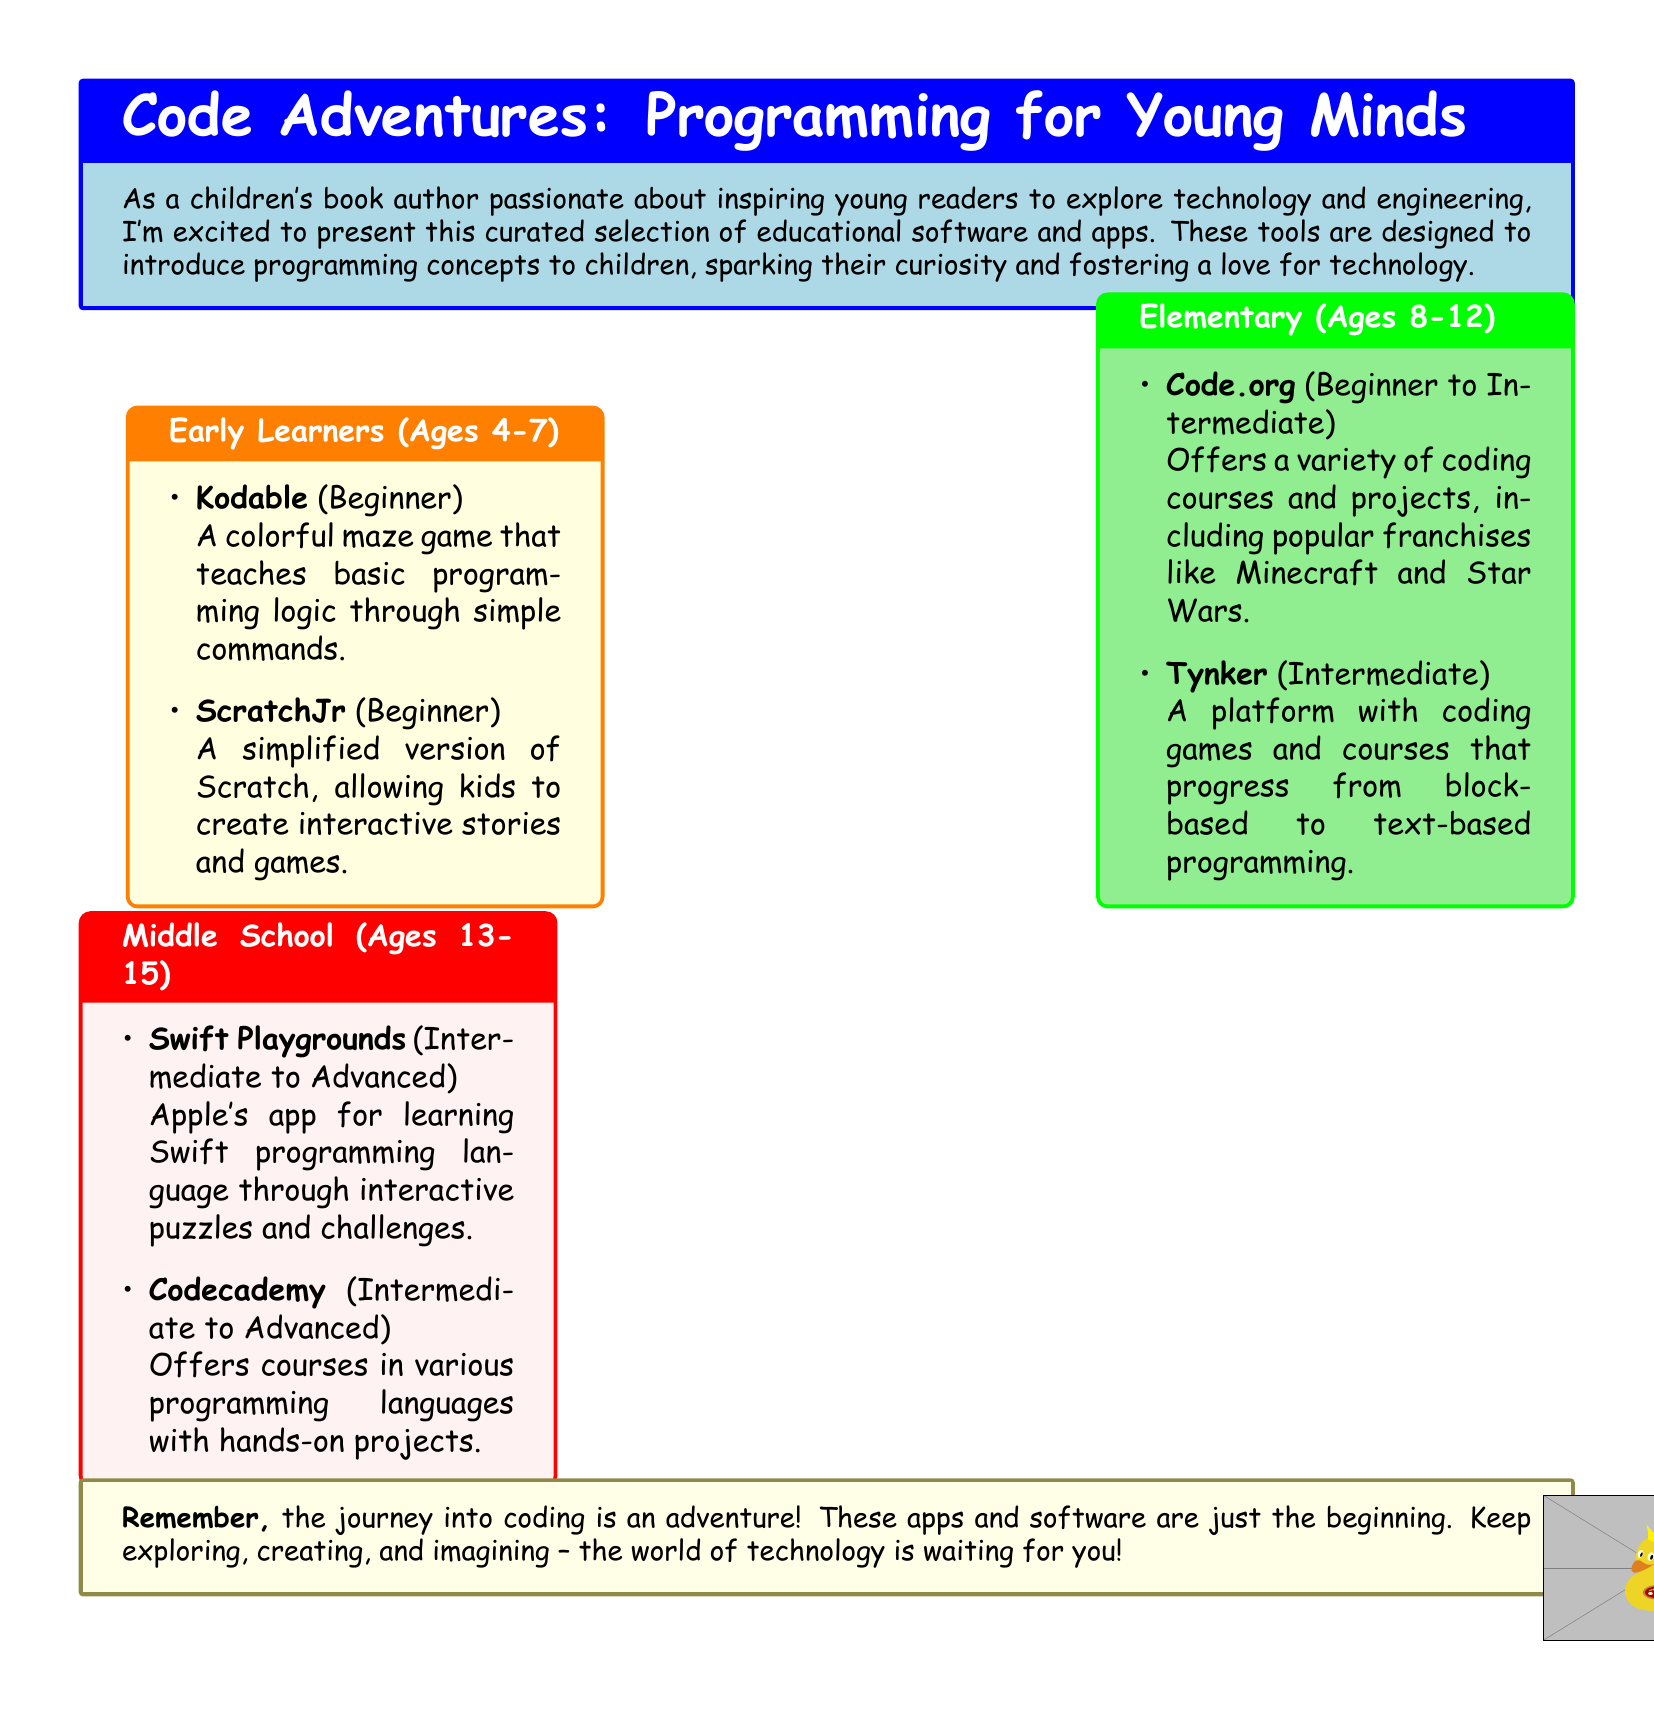What age group is Kodable designed for? Kodable is listed under Early Learners, which caters to ages 4-7.
Answer: Ages 4-7 What programming language does Swift Playgrounds teach? Swift Playgrounds is designed to help users learn the Swift programming language.
Answer: Swift How many apps are listed for Middle School? There are two apps mentioned in the Middle School section.
Answer: Two What is the difficulty level of Tynker? Tynker is categorized as Intermediate.
Answer: Intermediate What theme does Code.org incorporate in its coding courses? Code.org includes popular franchises like Minecraft and Star Wars in its courses.
Answer: Minecraft and Star Wars What color is the box for Elementary (Ages 8-12)? The box for Elementary is colored light green.
Answer: Light green Which app is designed specifically for ages 13-15? The app designed for ages 13-15 is listed under Middle School.
Answer: Swift Playgrounds Is ScratchJr a beginner or advanced tool? ScratchJr is categorized as a Beginner tool.
Answer: Beginner 